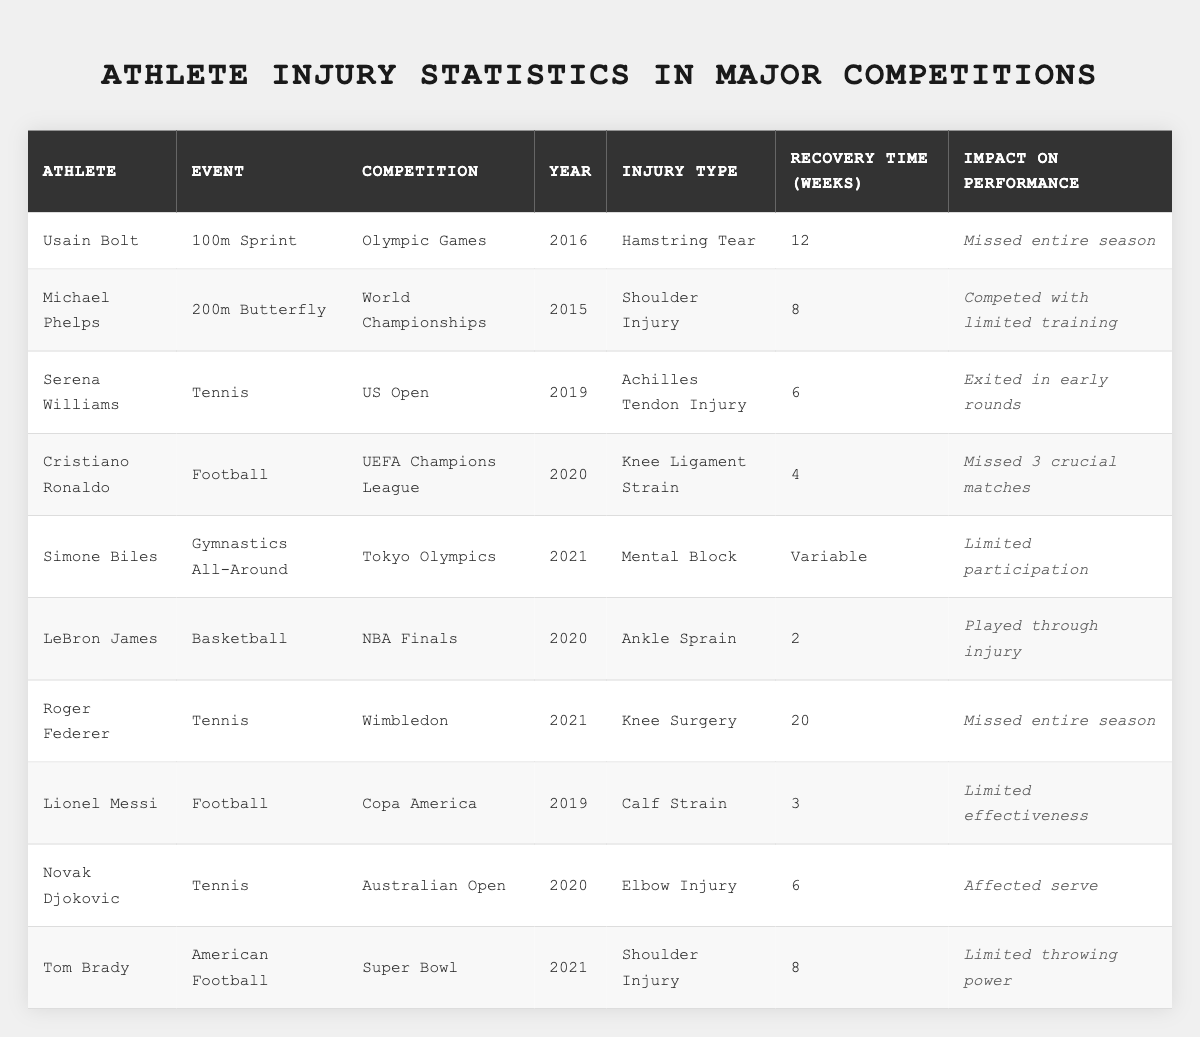What injury did Usain Bolt suffer in 2016? In the table, looking at Usain Bolt's entry, it states that he suffered from a "Hamstring Tear" in the year 2016.
Answer: Hamstring Tear How many weeks did Roger Federer require for recovery? By examining Roger Federer's row, it shows that he had a recovery time of "20" weeks due to a "Knee Surgery."
Answer: 20 weeks Which athlete had a "Mental Block" injury? Looking through the table, it indicates that Simone Biles had a "Mental Block" as her injury type in the Tokyo Olympics in 2021.
Answer: Simone Biles True or False: Lionel Messi's injury required more than 5 weeks to recover. In the table, Lionel Messi's injury recovery time is stated as "3" weeks, which is less than 5 weeks, making the assertion false.
Answer: False What is the average recovery time for the athletes listed? To find the average, sum up all the recovery times: 12 + 8 + 6 + 4 + (variable not counted) + 2 + 20 + 3 + 6 + 8 = 69 weeks across 9 athletes with recorded times, yielding an average of 69/9 = 7.67 weeks.
Answer: Approximately 7.67 weeks Which injury had the longest recovery time? By deducing from the table, Roger Federer had the longest recovery time of 20 weeks due to "Knee Surgery."
Answer: Roger Federer How many athletes missed the entire season due to injury? In the table, Usain Bolt and Roger Federer are noted as having missed the entire season, totaling 2 athletes.
Answer: 2 athletes Did any athlete compete despite being injured? The table indicates that LeBron James played through an injury (Ankle Sprain), thus the answer is affirmative.
Answer: Yes What type of injury did Novak Djokovic sustain? According to the table, Novak Djokovic's injury is listed as an "Elbow Injury."
Answer: Elbow Injury True or False: Serena Williams' injury had a recovery time of less than 7 weeks. Serena Williams had an "Achilles Tendon Injury" with a recovery time of 6 weeks, which is indeed less than 7 weeks, making the statement true.
Answer: True Which athlete faced limitations affecting their performance due to recovery? The table shows that Michael Phelps competed with limited training due to a "Shoulder Injury," indicating impact on his performance.
Answer: Michael Phelps 